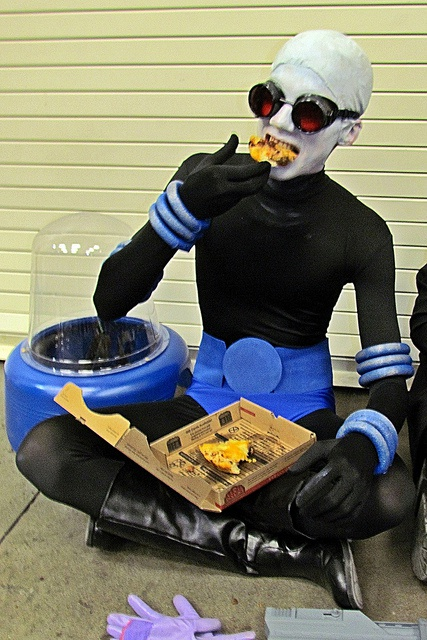Describe the objects in this image and their specific colors. I can see people in khaki, black, ivory, gray, and beige tones, people in khaki, black, beige, and darkgray tones, pizza in khaki, orange, gold, and brown tones, and pizza in khaki, orange, brown, and maroon tones in this image. 